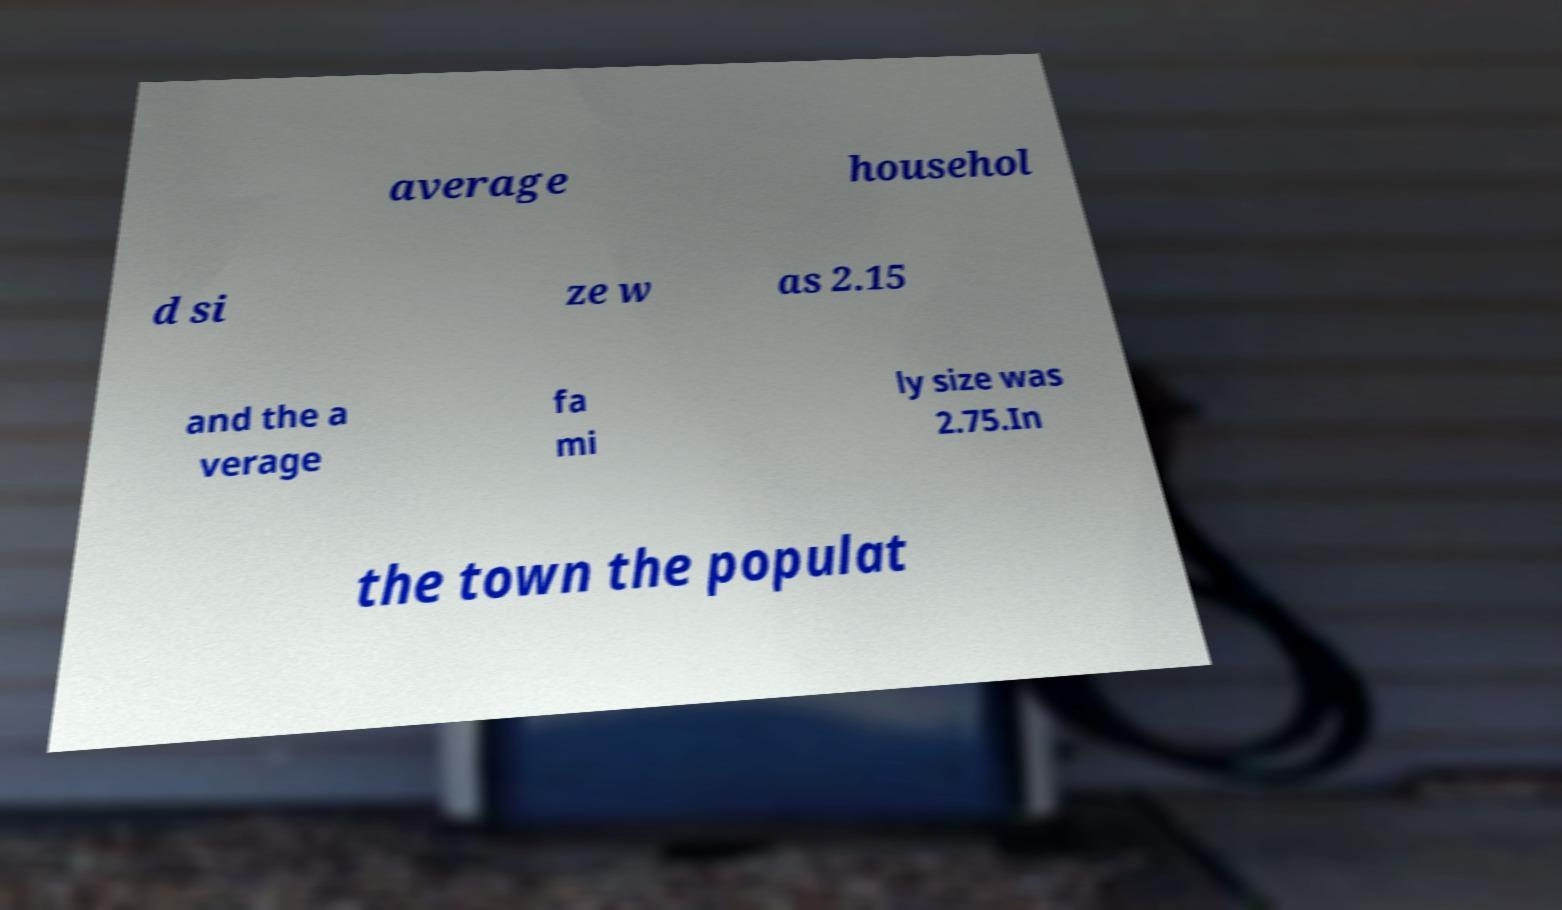Can you read and provide the text displayed in the image?This photo seems to have some interesting text. Can you extract and type it out for me? average househol d si ze w as 2.15 and the a verage fa mi ly size was 2.75.In the town the populat 